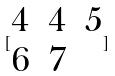Convert formula to latex. <formula><loc_0><loc_0><loc_500><loc_500>[ \begin{matrix} 4 & 4 & 5 \\ 6 & 7 \end{matrix} ]</formula> 